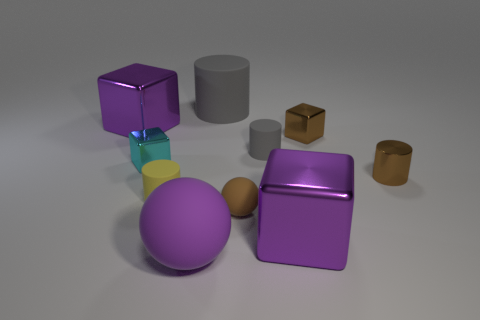Subtract all small yellow cylinders. How many cylinders are left? 3 Subtract 1 spheres. How many spheres are left? 1 Subtract all red blocks. How many gray cylinders are left? 2 Subtract all brown cubes. How many cubes are left? 3 Subtract all blocks. How many objects are left? 6 Subtract all brown cylinders. Subtract all cyan spheres. How many cylinders are left? 3 Subtract all small gray rubber cylinders. Subtract all large purple spheres. How many objects are left? 8 Add 7 large metallic things. How many large metallic things are left? 9 Add 1 tiny green metal spheres. How many tiny green metal spheres exist? 1 Subtract 0 green balls. How many objects are left? 10 